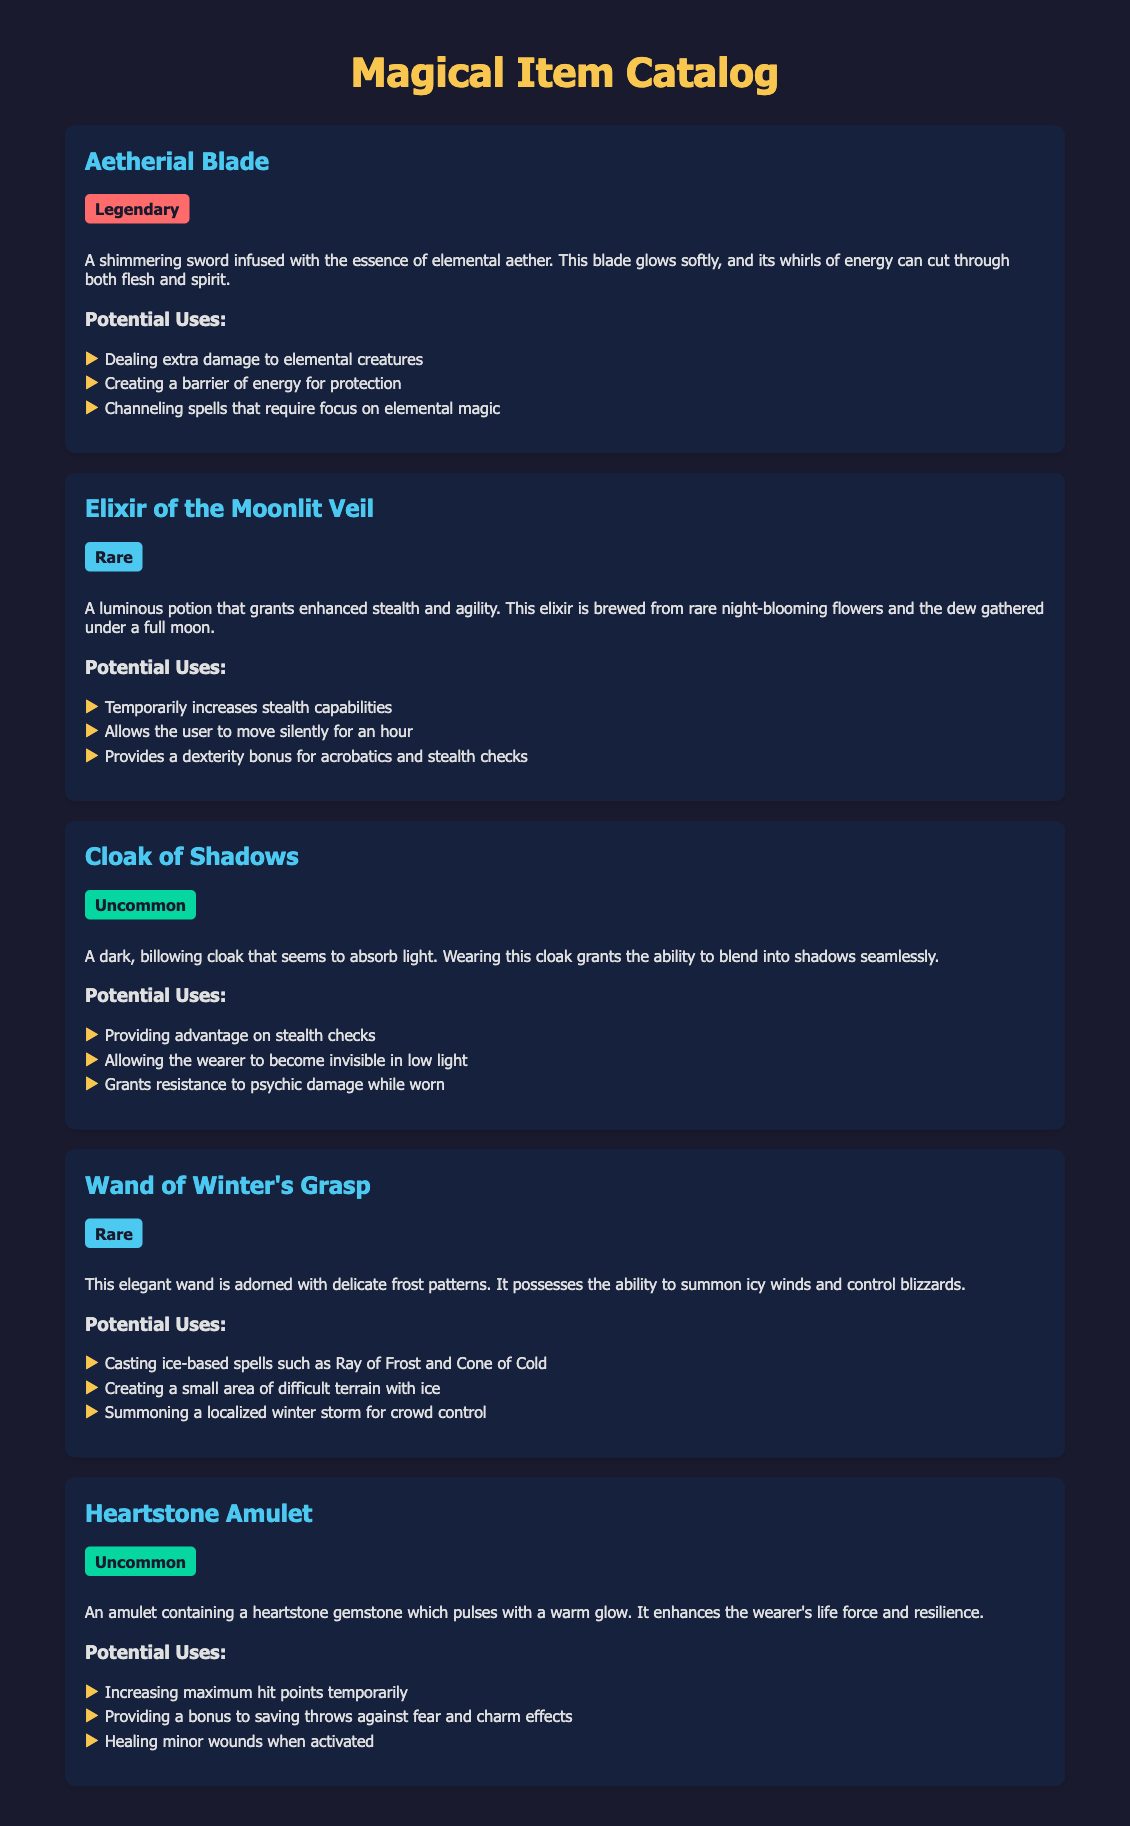What is the title of the document? The title of the document is displayed prominently at the top of the rendered page.
Answer: Magical Item Catalog How many items are listed in the catalog? There are five items presented in the catalog.
Answer: 5 What is the rarity classification of the Aetherial Blade? The rarity is indicated right below the item title in the description.
Answer: Legendary What potion grants enhanced stealth? The document specifies the name of the potion that provides stealth-enhancements as part of the descriptions.
Answer: Elixir of the Moonlit Veil What type of spells can the Wand of Winter's Grasp cast? The uses section describes specific spells associated with the Wand.
Answer: Ice-based spells Which item provides a bonus to saving throws against fear? The Heartstone Amulet's potential uses highlight its benefits regarding saving throws.
Answer: Heartstone Amulet What effect does the Cloak of Shadows have in low light? The document explains the benefit regarding invisibility when in low light conditions.
Answer: Invisibility Name an item that increases maximum hit points temporarily. Potential uses detail which items have healing or health-enhancing effects.
Answer: Heartstone Amulet What is the effect of the Elixir of the Moonlit Veil on movement? The description outlines how the elixir affects the user's movement capabilities.
Answer: Move silently 